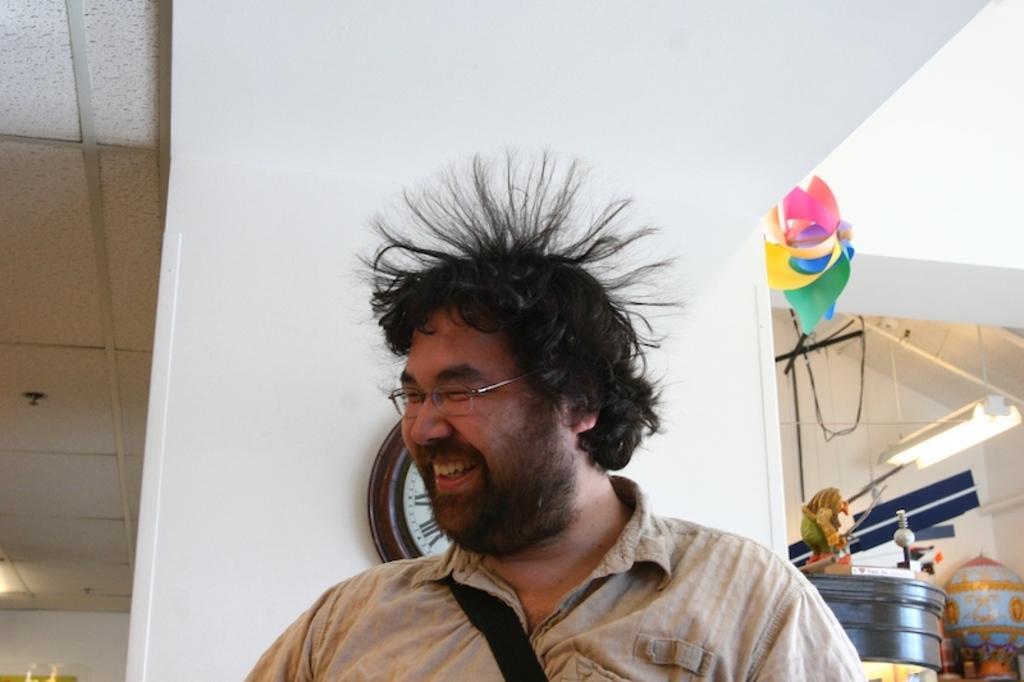Could you give a brief overview of what you see in this image? As we can see in the image there is a white color wall, clock, drum and a man standing in the front. 